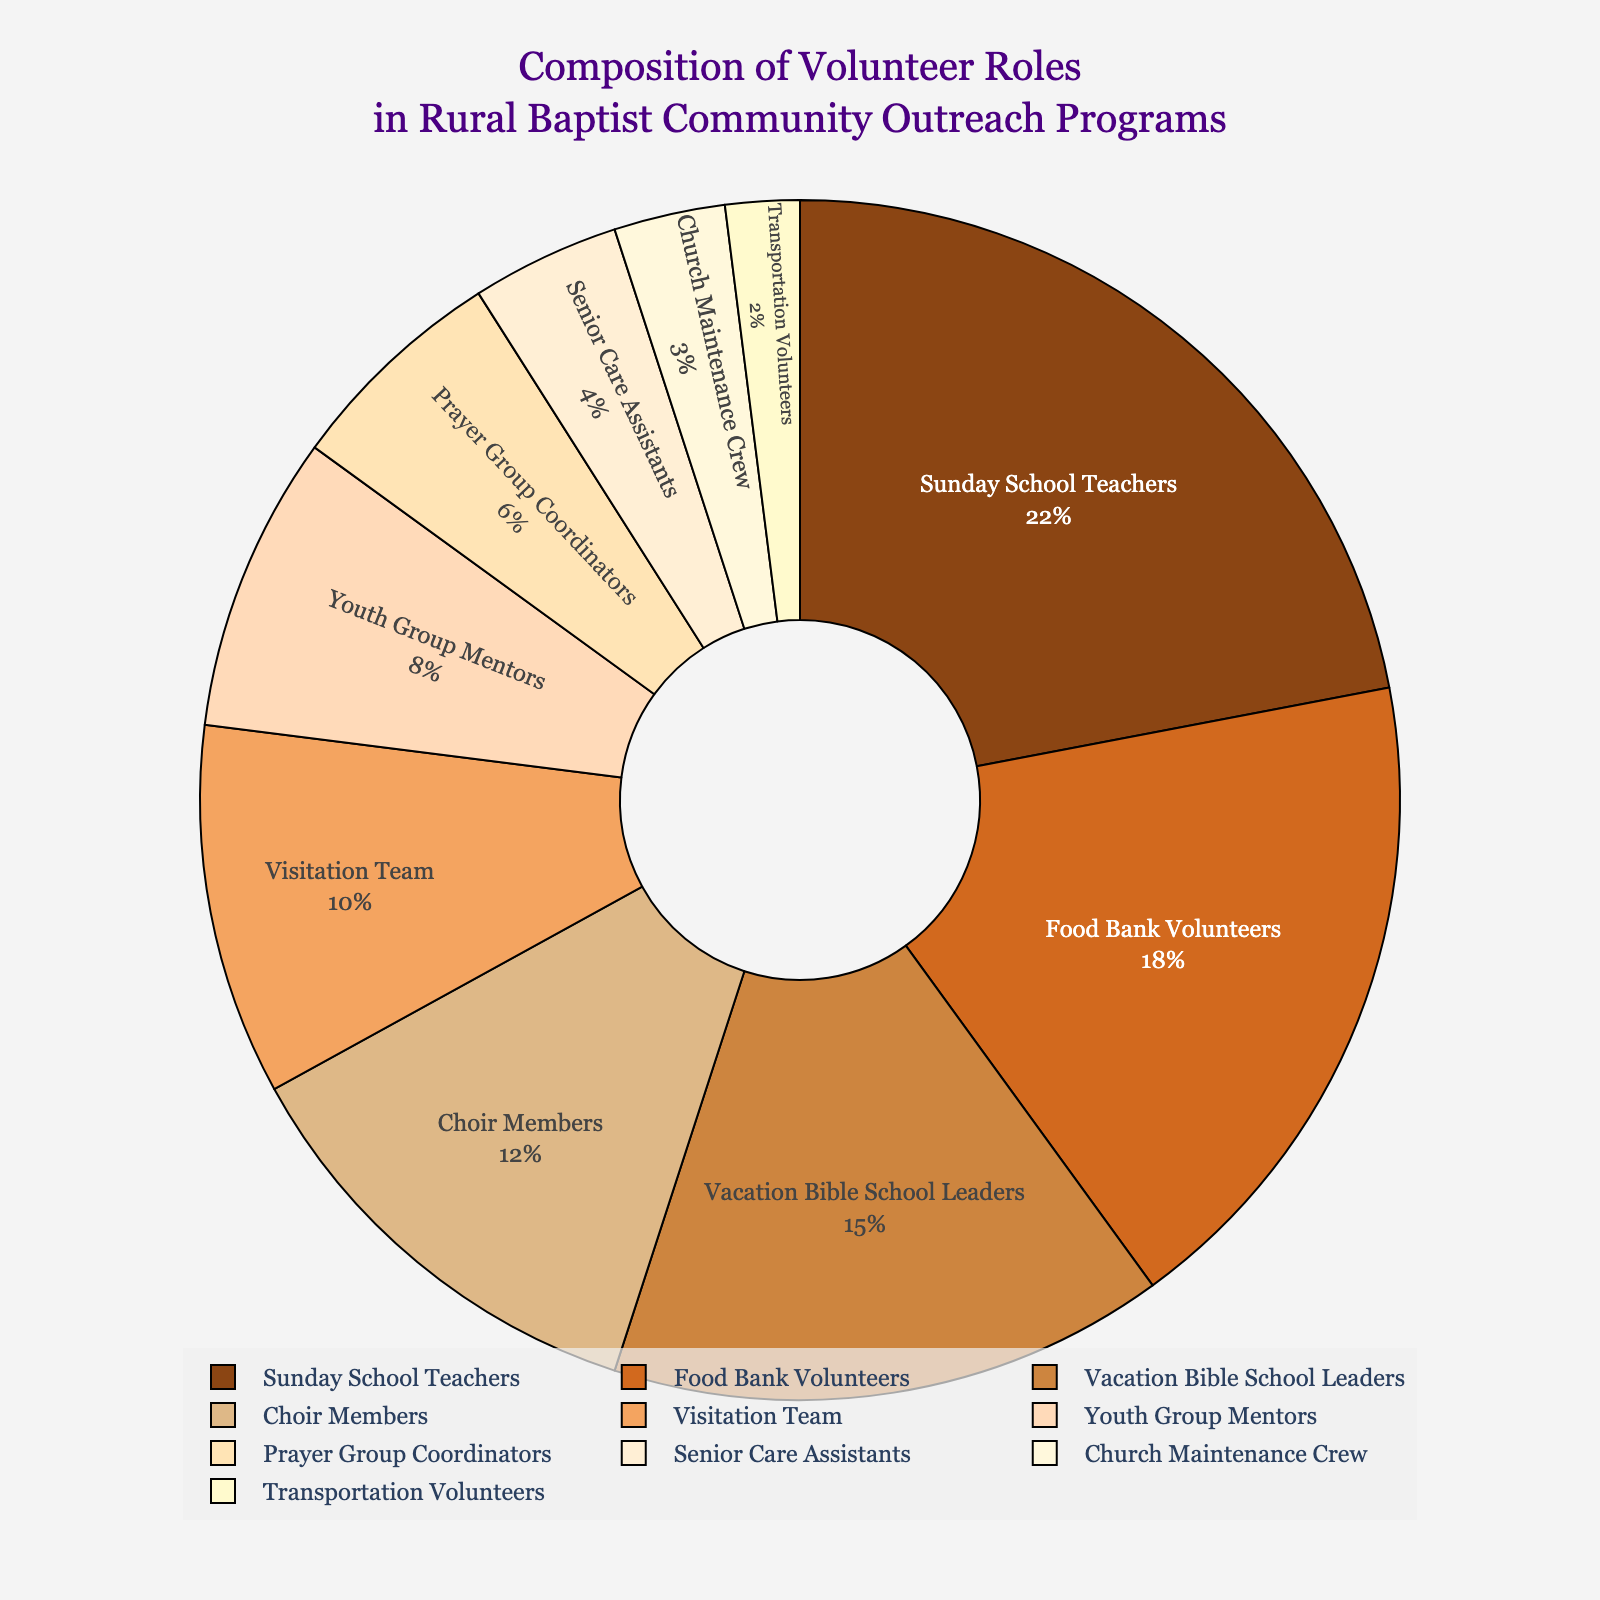What role has the highest percentage in the pie chart? To determine the role with the highest percentage, look for the largest segment in the pie chart, which corresponds to "Sunday School Teachers" at 22%.
Answer: Sunday School Teachers Which volunteer role has the smallest percentage in the pie chart? Identify the smallest segment in the pie chart, which represents "Transportation Volunteers" at 2%.
Answer: Transportation Volunteers What is the combined percentage of Food Bank Volunteers and Vacation Bible School Leaders? Add the percentages of Food Bank Volunteers (18%) and Vacation Bible School Leaders (15%): 18% + 15% = 33%.
Answer: 33% How does the percentage of Choir Members compare to Senior Care Assistants? Compare the percentages: Choir Members have 12%, while Senior Care Assistants have 4%. The difference is 12% - 4% = 8%.
Answer: 8% Are Sunday School Teachers' and Youth Group Mentors' combined percentages more than half of the total? Add the percentages: Sunday School Teachers (22%) + Youth Group Mentors (8%) = 30%. Since 30% is less than 50%, they're not more than half.
Answer: No Which roles have percentages that are closer to each other: Food Bank Volunteers and Vacation Bible School Leaders, or Choir Members and Visitation Team? Calculate the differences: (18% - 15% = 3%) for Food Bank Volunteers and Vacation Bible School Leaders, and (12% - 10% = 2%) for Choir Members and Visitation Team. Choir Members and Visitation Team have closer percentages.
Answer: Choir Members and Visitation Team What is the difference between the largest and smallest percentages? Subtract the smallest percentage (Transportation Volunteers, 2%) from the largest (Sunday School Teachers, 22%): 22% - 2% = 20%.
Answer: 20% List the roles that have more than 10% of volunteers each. Identify the segments larger than 10%: Sunday School Teachers (22%), Food Bank Volunteers (18%), Vacation Bible School Leaders (15%), and Choir Members (12%).
Answer: Sunday School Teachers, Food Bank Volunteers, Vacation Bible School Leaders, Choir Members What is the combined percentage of the roles that are less than 5% each? Add the percentages of roles less than 5%: Senior Care Assistants (4%), Church Maintenance Crew (3%), and Transportation Volunteers (2%). Total is 4% + 3% + 2% = 9%.
Answer: 9% Which role is represented by the darkest color in the pie chart? Identify the specific color associated with the darkest segment and its corresponding role. Refer to the color order given (#8B4513 being the darkest): the role is "Sunday School Teachers".
Answer: Sunday School Teachers 